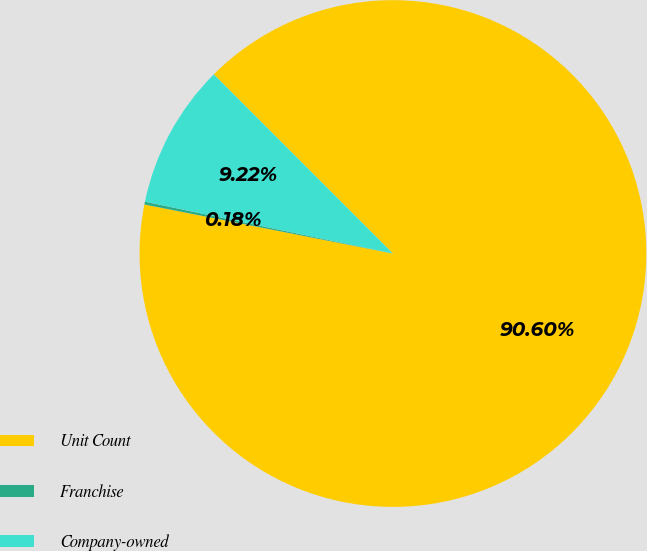Convert chart. <chart><loc_0><loc_0><loc_500><loc_500><pie_chart><fcel>Unit Count<fcel>Franchise<fcel>Company-owned<nl><fcel>90.6%<fcel>0.18%<fcel>9.22%<nl></chart> 